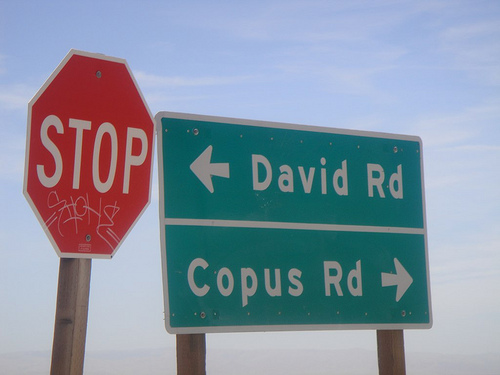Read and extract the text from this image. STOP David Rd Copus Rd 